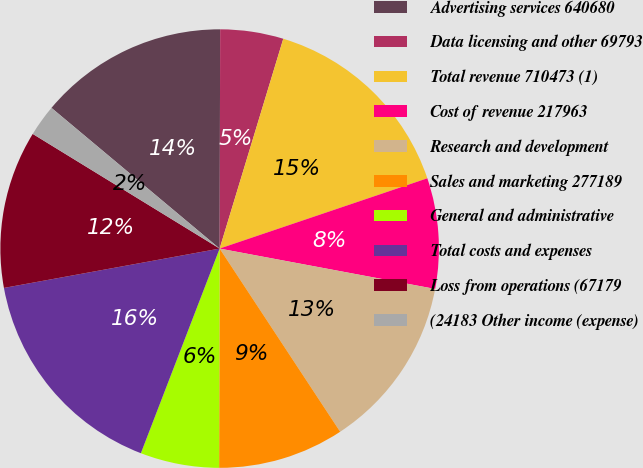<chart> <loc_0><loc_0><loc_500><loc_500><pie_chart><fcel>Advertising services 640680<fcel>Data licensing and other 69793<fcel>Total revenue 710473 (1)<fcel>Cost of revenue 217963<fcel>Research and development<fcel>Sales and marketing 277189<fcel>General and administrative<fcel>Total costs and expenses<fcel>Loss from operations (67179<fcel>(24183 Other income (expense)<nl><fcel>13.95%<fcel>4.65%<fcel>15.12%<fcel>8.14%<fcel>12.79%<fcel>9.3%<fcel>5.81%<fcel>16.28%<fcel>11.63%<fcel>2.33%<nl></chart> 